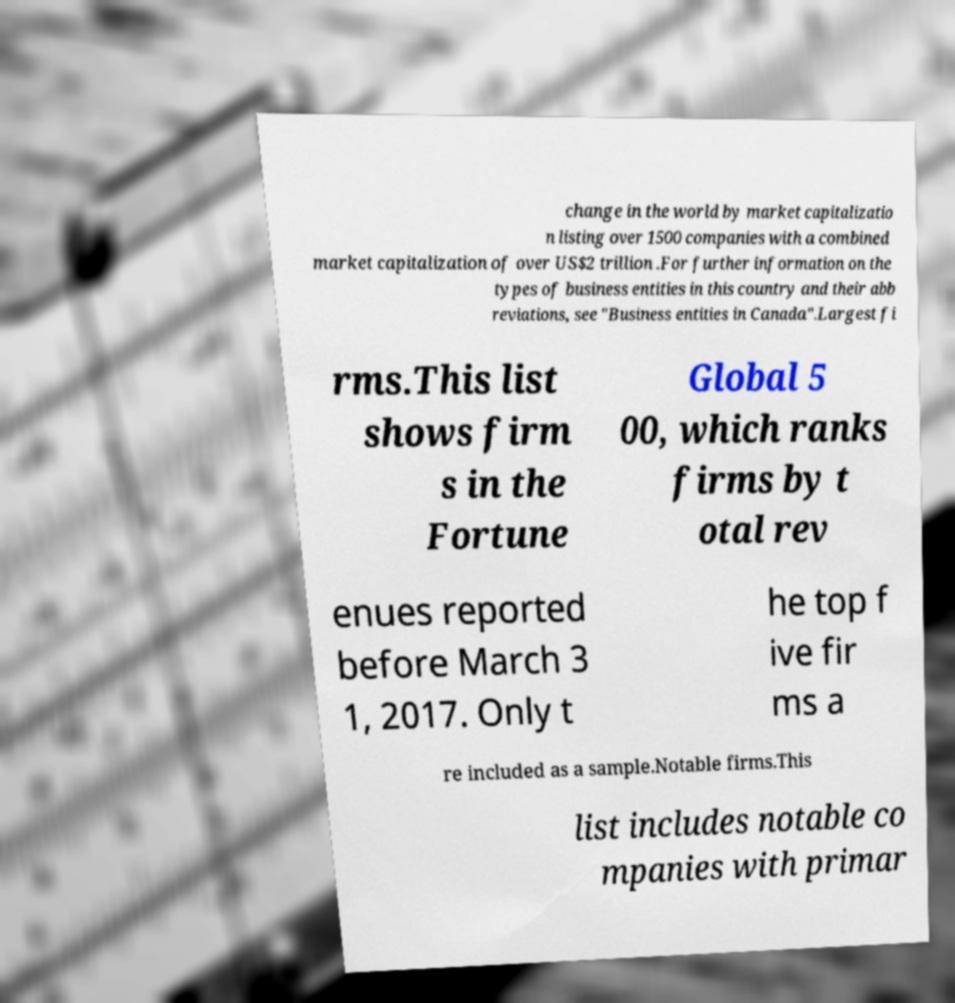For documentation purposes, I need the text within this image transcribed. Could you provide that? change in the world by market capitalizatio n listing over 1500 companies with a combined market capitalization of over US$2 trillion .For further information on the types of business entities in this country and their abb reviations, see "Business entities in Canada".Largest fi rms.This list shows firm s in the Fortune Global 5 00, which ranks firms by t otal rev enues reported before March 3 1, 2017. Only t he top f ive fir ms a re included as a sample.Notable firms.This list includes notable co mpanies with primar 